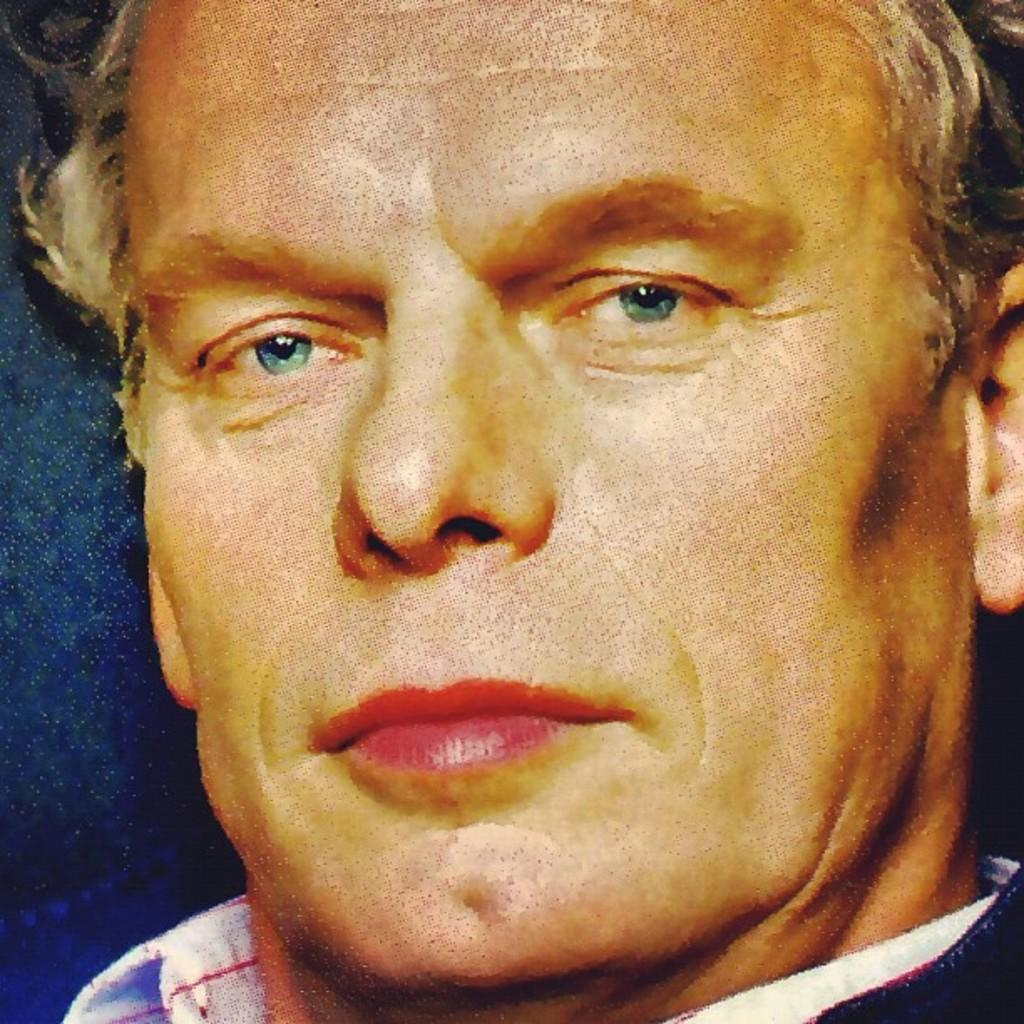What is the main subject of the image? There is a man's face in the image. What type of bread is being used to stop the ring from falling in the image? There is no bread or ring present in the image; it only features a man's face. 